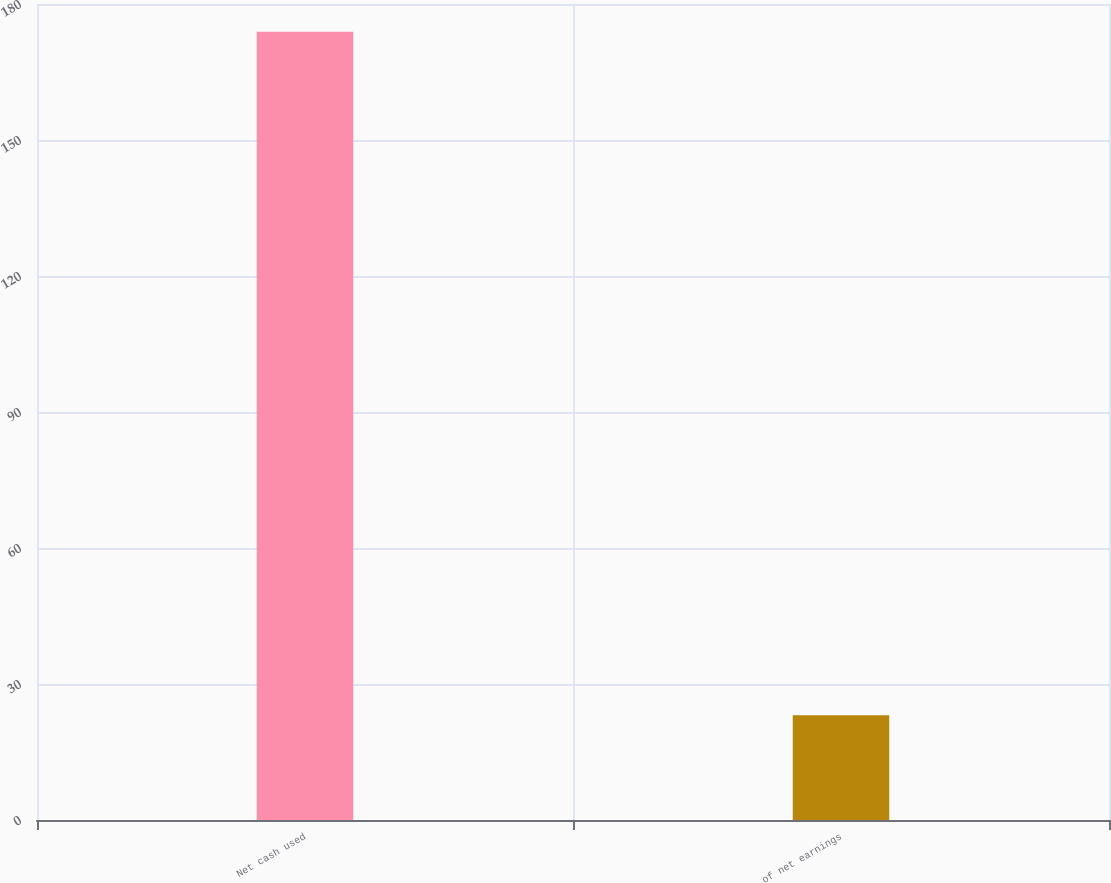<chart> <loc_0><loc_0><loc_500><loc_500><bar_chart><fcel>Net cash used<fcel>of net earnings<nl><fcel>173.9<fcel>23.1<nl></chart> 